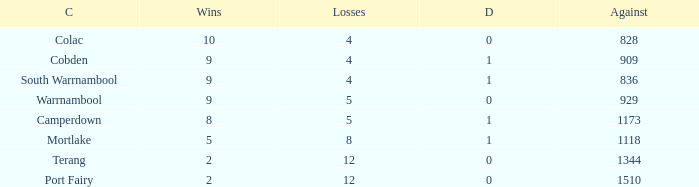What is the average number of draws for losses over 8 and Against values under 1344? None. 